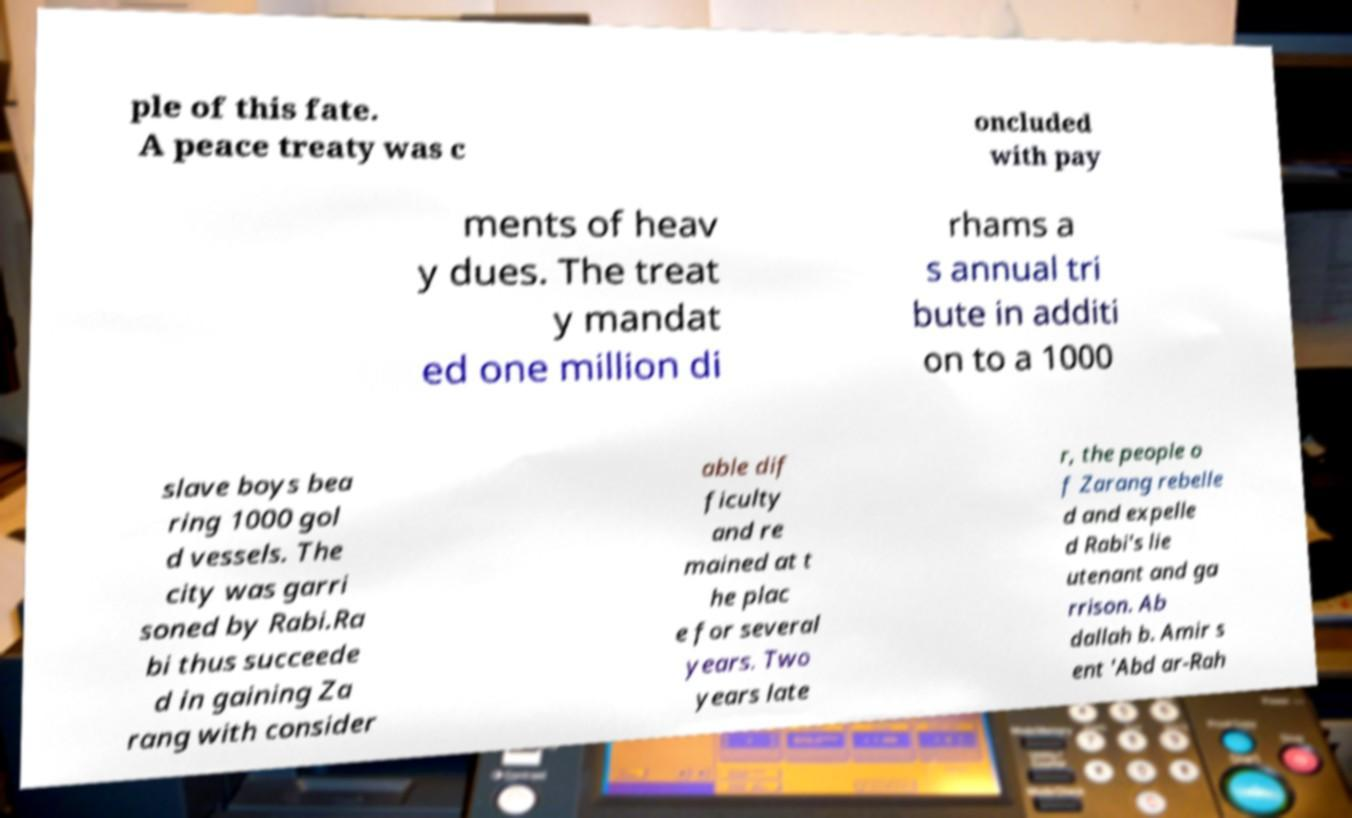Please read and relay the text visible in this image. What does it say? ple of this fate. A peace treaty was c oncluded with pay ments of heav y dues. The treat y mandat ed one million di rhams a s annual tri bute in additi on to a 1000 slave boys bea ring 1000 gol d vessels. The city was garri soned by Rabi.Ra bi thus succeede d in gaining Za rang with consider able dif ficulty and re mained at t he plac e for several years. Two years late r, the people o f Zarang rebelle d and expelle d Rabi's lie utenant and ga rrison. Ab dallah b. Amir s ent 'Abd ar-Rah 